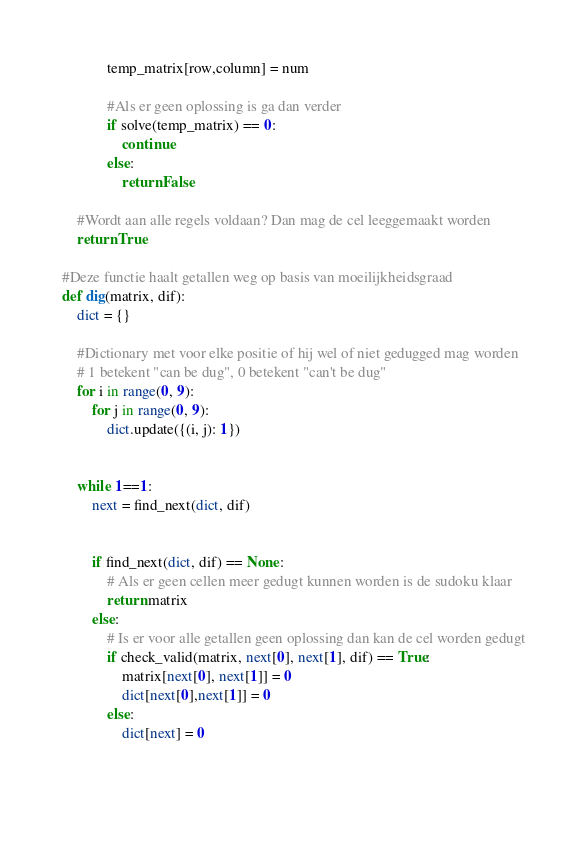Convert code to text. <code><loc_0><loc_0><loc_500><loc_500><_Python_>            temp_matrix[row,column] = num

            #Als er geen oplossing is ga dan verder
            if solve(temp_matrix) == 0:
                continue
            else:
                return False

    #Wordt aan alle regels voldaan? Dan mag de cel leeggemaakt worden
    return True

#Deze functie haalt getallen weg op basis van moeilijkheidsgraad
def dig(matrix, dif):
    dict = {}

    #Dictionary met voor elke positie of hij wel of niet gedugged mag worden
    # 1 betekent "can be dug", 0 betekent "can't be dug"
    for i in range(0, 9):
        for j in range(0, 9):
            dict.update({(i, j): 1})


    while 1==1:
        next = find_next(dict, dif)


        if find_next(dict, dif) == None:
            # Als er geen cellen meer gedugt kunnen worden is de sudoku klaar
            return matrix
        else:
            # Is er voor alle getallen geen oplossing dan kan de cel worden gedugt
            if check_valid(matrix, next[0], next[1], dif) == True:
                matrix[next[0], next[1]] = 0
                dict[next[0],next[1]] = 0
            else:
                dict[next] = 0


        







</code> 